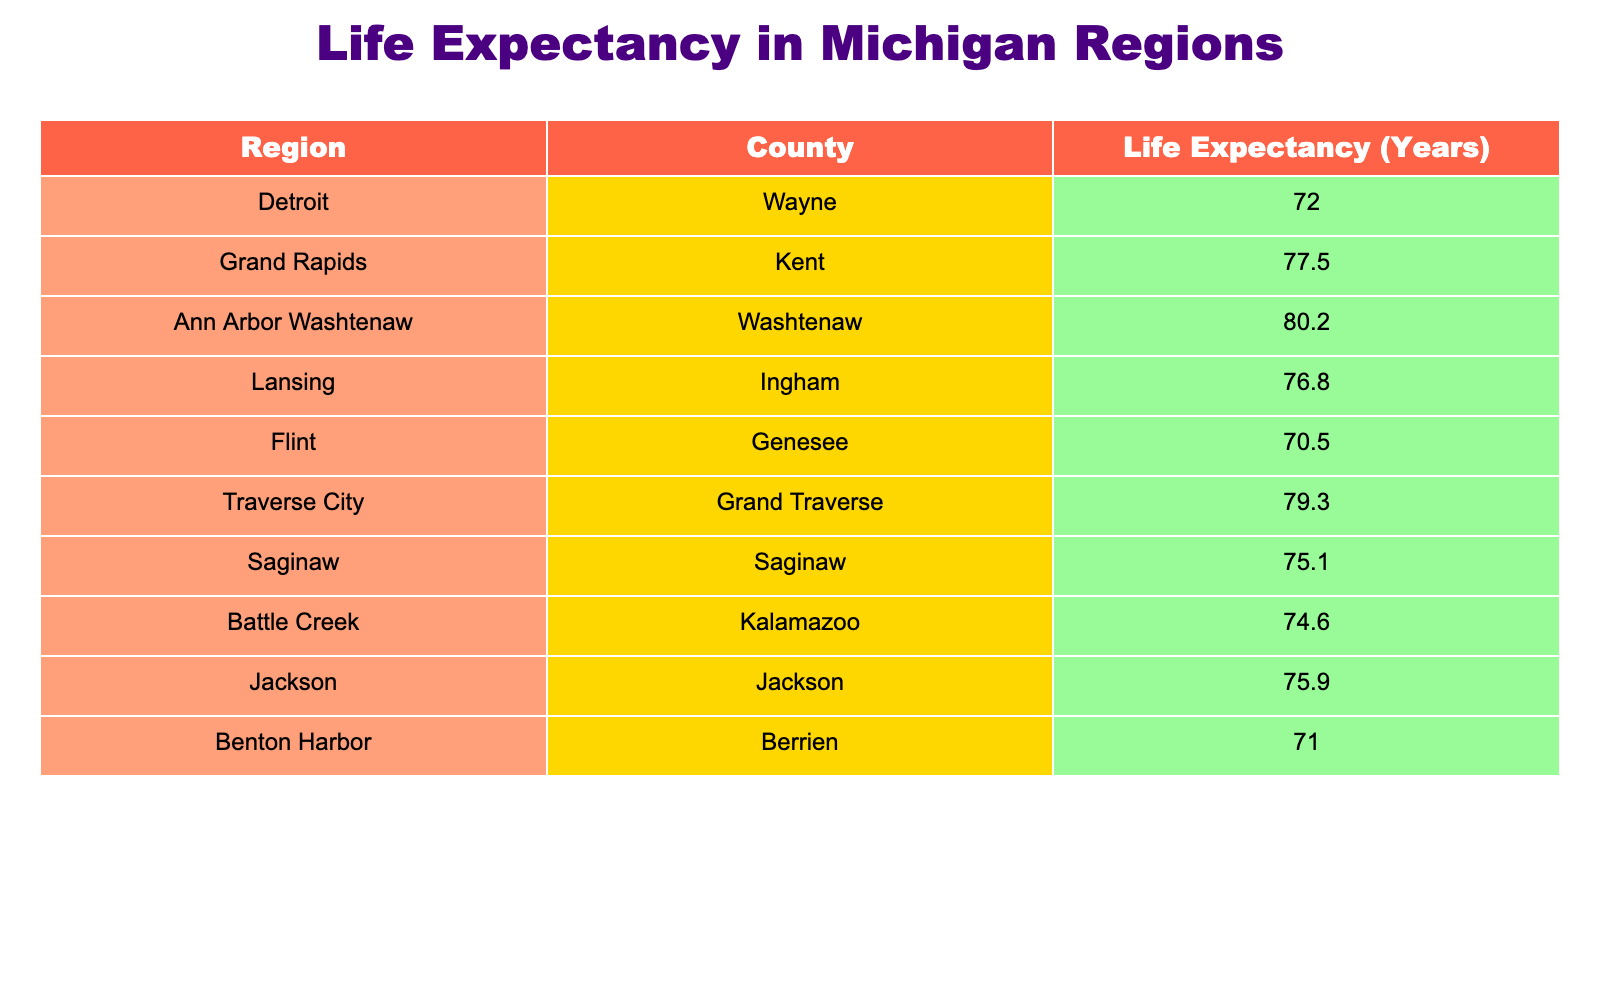What is the life expectancy in Detroit? The table shows a specific entry for Detroit, Wayne with a life expectancy of 72.0 years.
Answer: 72.0 Which region has the highest life expectancy? By comparing the life expectancies listed for each region, Ann Arbor, Washtenaw has the highest life expectancy at 80.2 years.
Answer: 80.2 What is the difference in life expectancy between Flint and Grand Rapids? Flint has a life expectancy of 70.5 years, while Grand Rapids has 77.5 years. The difference is calculated as 77.5 - 70.5 = 7.0 years.
Answer: 7.0 Is the life expectancy in Battle Creek higher than in Saginaw? Life expectancy in Battle Creek is 74.6 years, while in Saginaw it is 75.1 years. Thus, Battle Creek's life expectancy is not higher than Saginaw's.
Answer: No What is the average life expectancy of the listed cities? To find the average, sum all life expectancies (72.0 + 77.5 + 80.2 + 76.8 + 70.5 + 79.3 + 75.1 + 74.6 + 75.9 + 71.0) =  62.1 / 10 = 75.56 years.
Answer: 75.56 How many regions have a life expectancy below 75 years? By examining the table, we see that Detroit (72.0), Flint (70.5), and Benton Harbor (71.0) are the regions below 75 years, which totals three regions.
Answer: 3 What is the median life expectancy among the regions given? To find the median, list the life expectancies in ascending order: 70.5, 71.0, 72.0, 74.6, 75.1, 75.9, 76.8, 77.5, 79.3, 80.2. The median is the average of the 5th and 6th values (75.1 and 75.9), calculated as (75.1 + 75.9)/2 = 75.5 years.
Answer: 75.5 Which county has the lowest life expectancy? By scanning the table, Flint, Genesee has the lowest life expectancy at 70.5 years.
Answer: 70.5 Does Grand Rapids have a higher life expectancy than both Jackson and Saginaw combined? Grand Rapids has a life expectancy of 77.5 years, Jackson has 75.9 years, and Saginaw has 75.1 years. Adding Jackson and Saginaw gives 75.9 + 75.1 = 151.0 years, while Grand Rapids alone has less when compared to the average of Jackson and Saginaw, which is (151.0 / 2) = 75.5. So, Grand Rapids does have a higher life expectancy.
Answer: Yes 